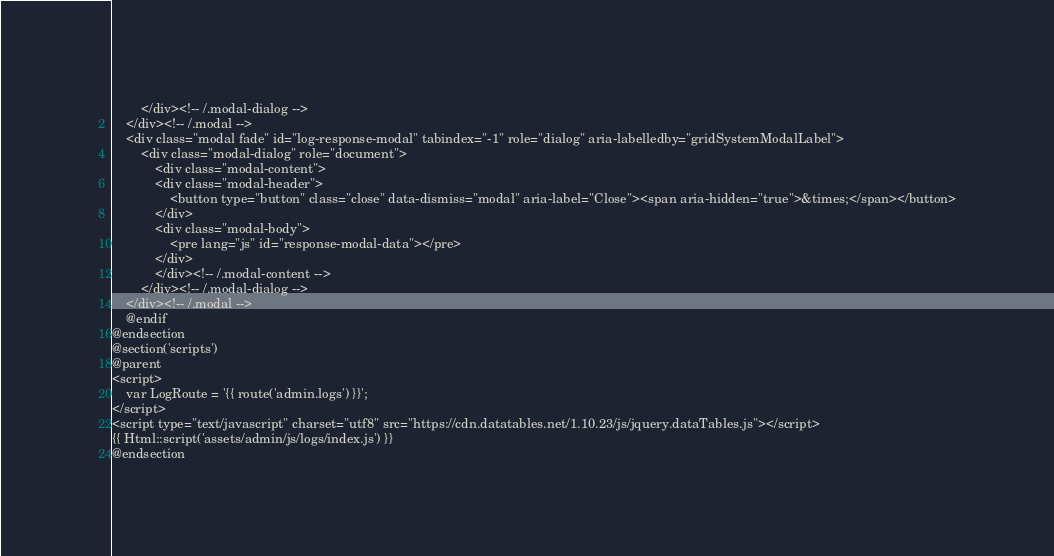<code> <loc_0><loc_0><loc_500><loc_500><_PHP_>        </div><!-- /.modal-dialog -->
    </div><!-- /.modal -->
    <div class="modal fade" id="log-response-modal" tabindex="-1" role="dialog" aria-labelledby="gridSystemModalLabel">
        <div class="modal-dialog" role="document">
            <div class="modal-content">
            <div class="modal-header">
                <button type="button" class="close" data-dismiss="modal" aria-label="Close"><span aria-hidden="true">&times;</span></button>
            </div>
            <div class="modal-body">
                <pre lang="js" id="response-modal-data"></pre>
            </div>
            </div><!-- /.modal-content -->
        </div><!-- /.modal-dialog -->
    </div><!-- /.modal -->
    @endif
@endsection
@section('scripts')
@parent
<script>
    var LogRoute = '{{ route('admin.logs') }}';
</script>
<script type="text/javascript" charset="utf8" src="https://cdn.datatables.net/1.10.23/js/jquery.dataTables.js"></script>
{{ Html::script('assets/admin/js/logs/index.js') }}
@endsection
</code> 